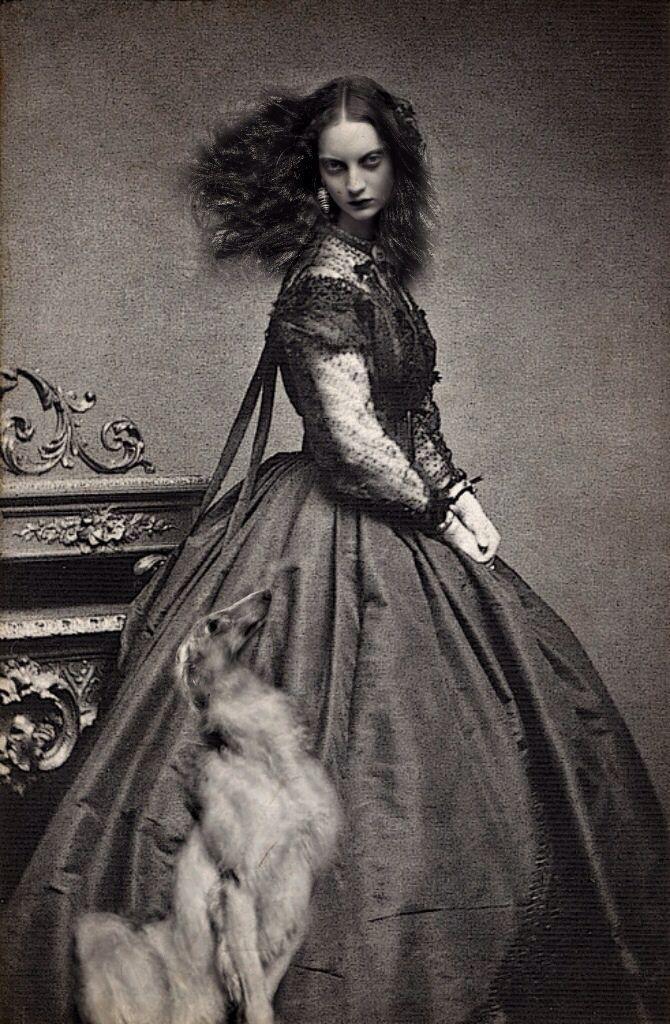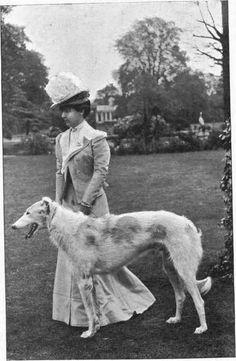The first image is the image on the left, the second image is the image on the right. Considering the images on both sides, is "In one image, afghans are on leashes, and a man is on the left of a woman in a blowing skirt." valid? Answer yes or no. No. The first image is the image on the left, the second image is the image on the right. Examine the images to the left and right. Is the description "There are three people and three dogs." accurate? Answer yes or no. No. 